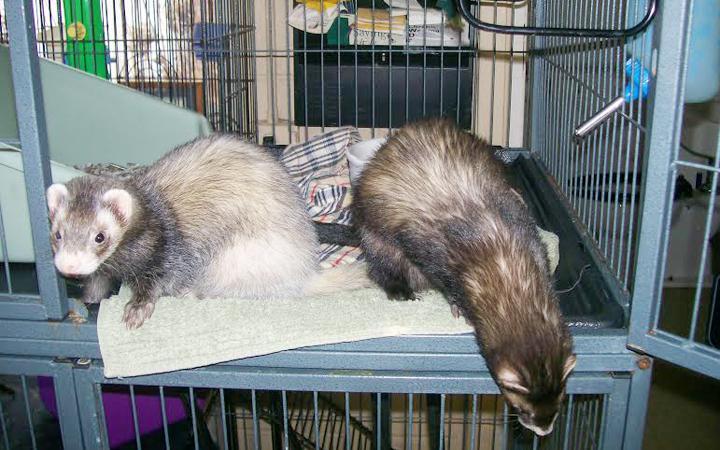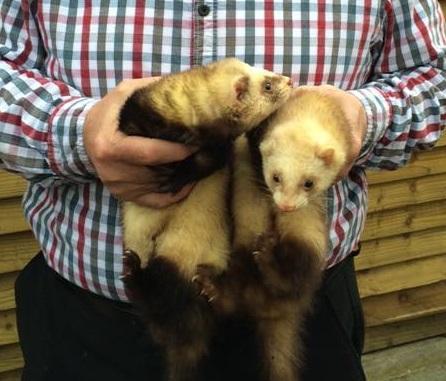The first image is the image on the left, the second image is the image on the right. For the images displayed, is the sentence "An image contains a human holding two ferrets." factually correct? Answer yes or no. Yes. 